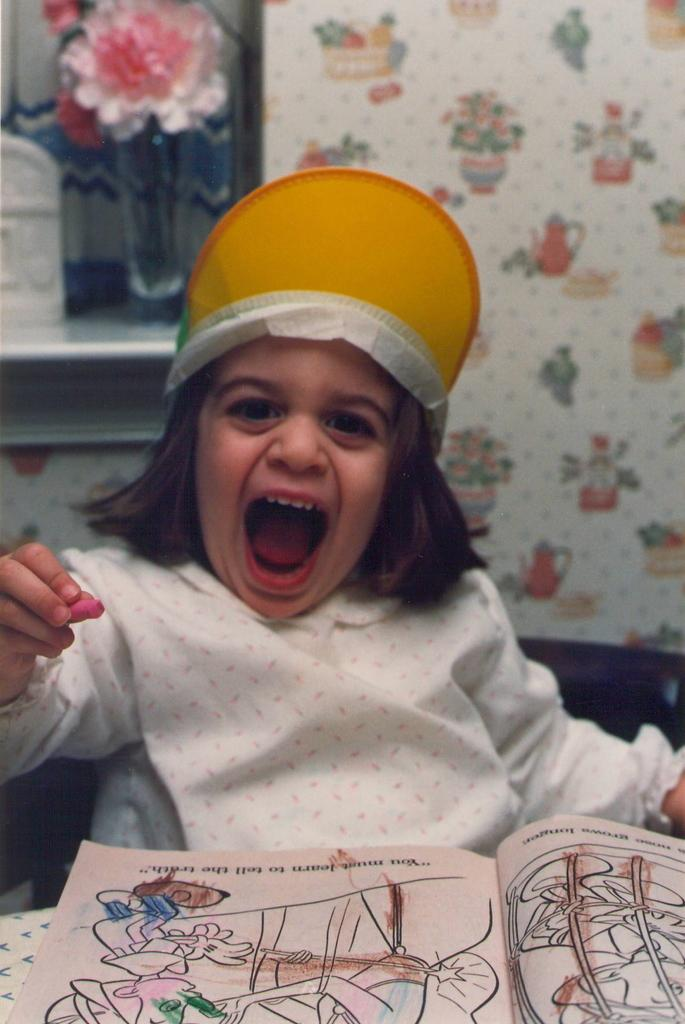Who is the main subject in the image? There is a girl in the image. What is the girl wearing on her head? The girl is wearing a cap. What is the girl holding in her hand? The girl is holding a crayon. What object is on the table in the image? There is a drawing book on the table. What decorative item can be seen on the wall behind the girl? There is a flower vase on the wall behind the girl. Can you tell me who the girl is fighting with in the image? There is no fight or any indication of conflict in the image. 